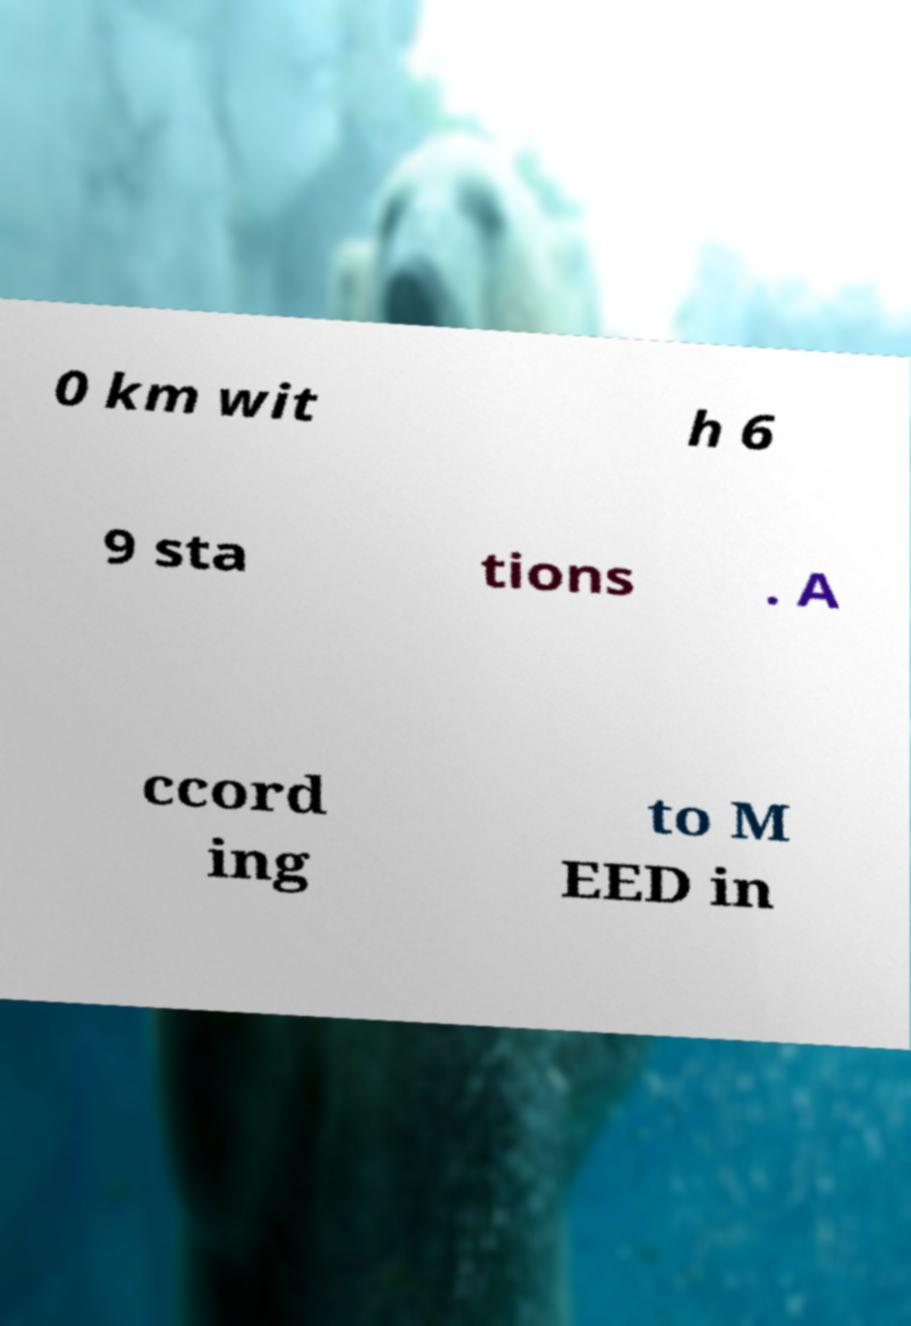Can you accurately transcribe the text from the provided image for me? 0 km wit h 6 9 sta tions . A ccord ing to M EED in 